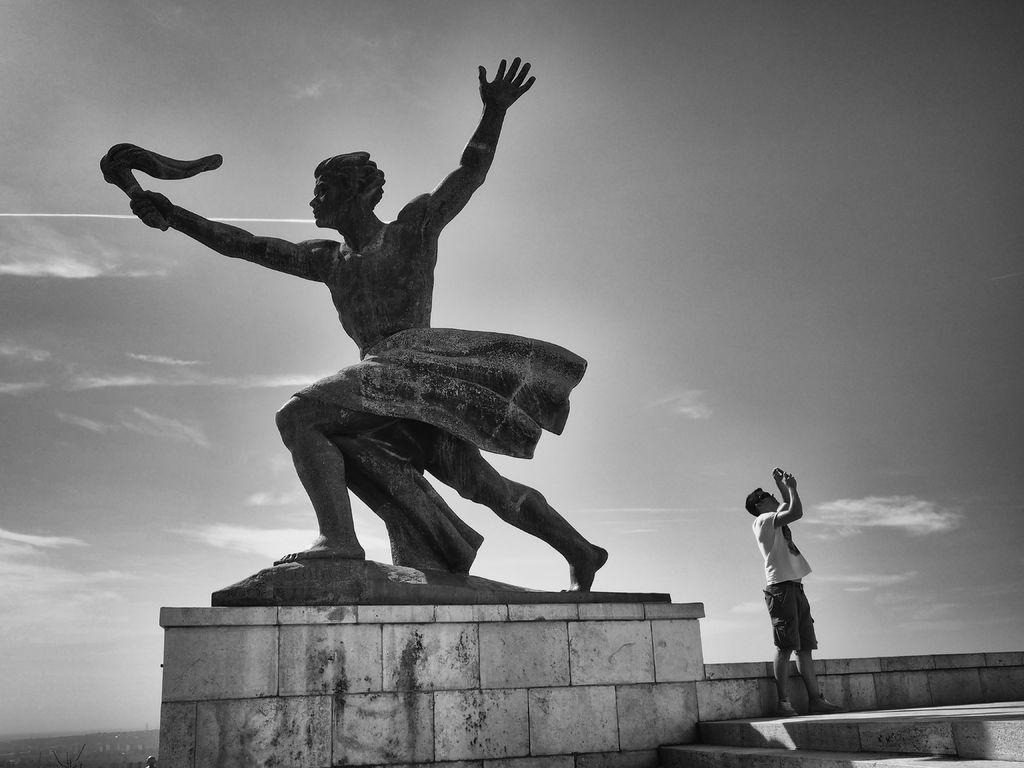What is the main subject in the image? There is a statue in the image. Can you describe the person in the image? There is a person standing near a wall in the image. What can be seen in the background of the image? The sky is visible in the background of the image. Who is the creator of the key in the image? There is no key present in the image, so it is not possible to determine who created it. 